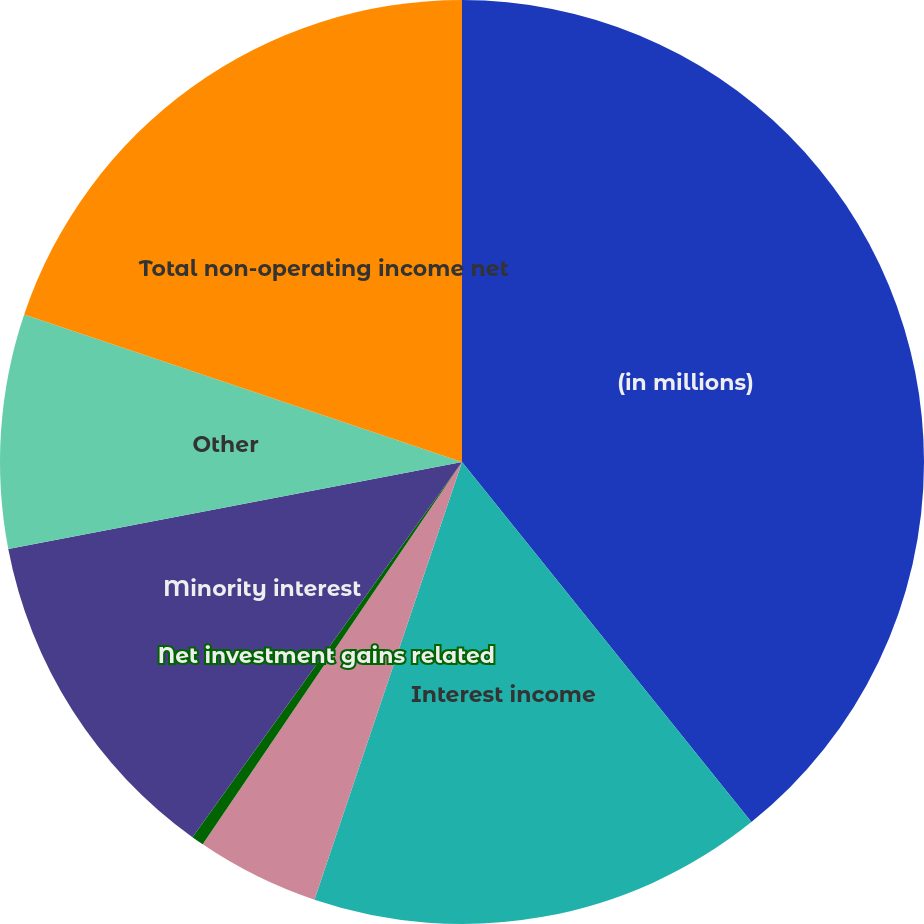Convert chart. <chart><loc_0><loc_0><loc_500><loc_500><pie_chart><fcel>(in millions)<fcel>Interest income<fcel>Foreign currency gains<fcel>Net investment gains related<fcel>Minority interest<fcel>Other<fcel>Total non-operating income net<nl><fcel>39.23%<fcel>15.95%<fcel>4.31%<fcel>0.43%<fcel>12.07%<fcel>8.19%<fcel>19.83%<nl></chart> 